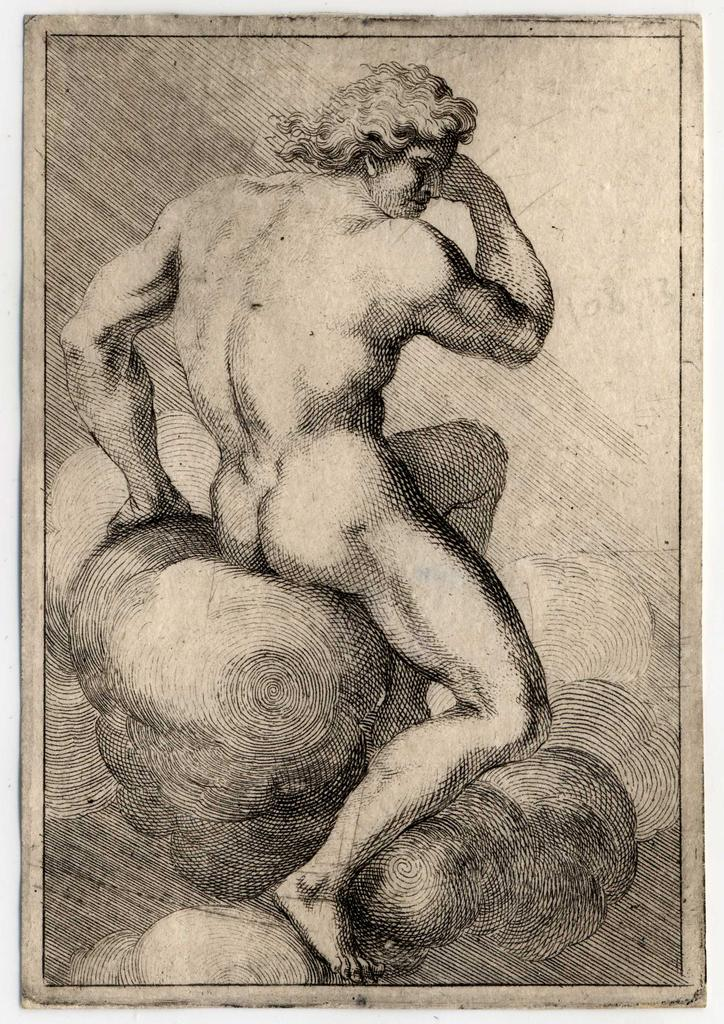What type of image is depicted in the poster? The image is a poster featuring a black and white figure drawing of a human. Can you describe the style or technique used in the drawing? The drawing is in black and white, which suggests it may be a sketch or line drawing. What is the subject matter of the drawing? The subject matter is a human figure. What type of flesh can be seen in the image? There is no flesh visible in the image, as it is a black and white figure drawing of a human. What song is being sung by the figure in the image? There is no indication of a song being sung in the image, as it is a static drawing of a human figure. 